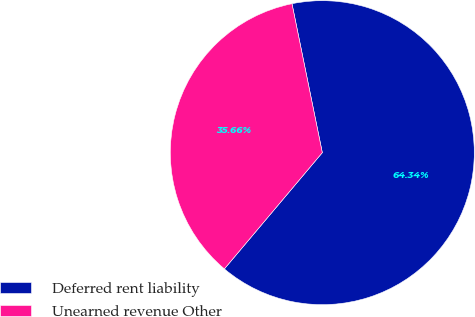Convert chart. <chart><loc_0><loc_0><loc_500><loc_500><pie_chart><fcel>Deferred rent liability<fcel>Unearned revenue Other<nl><fcel>64.34%<fcel>35.66%<nl></chart> 